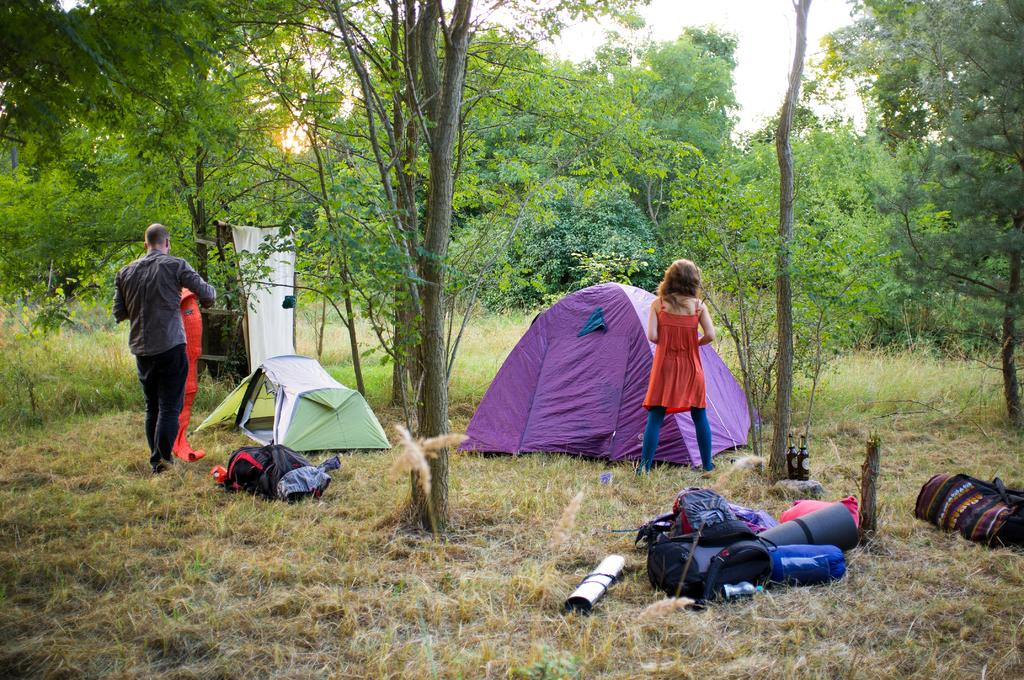What objects can be seen in the foreground of the image? There are backpacks and objects on the ground in the foreground of the image. What type of structures are present in the image? There are tents in the image. How many people are standing in the image? There is a man and a woman standing in the image. What natural elements can be seen in the image? Trees, the sky, and the sun are visible in the image. What type of record can be seen in the image? There is no record present in the image. What caption is written on the image? The image does not have a caption; it is a visual representation without any accompanying text. 